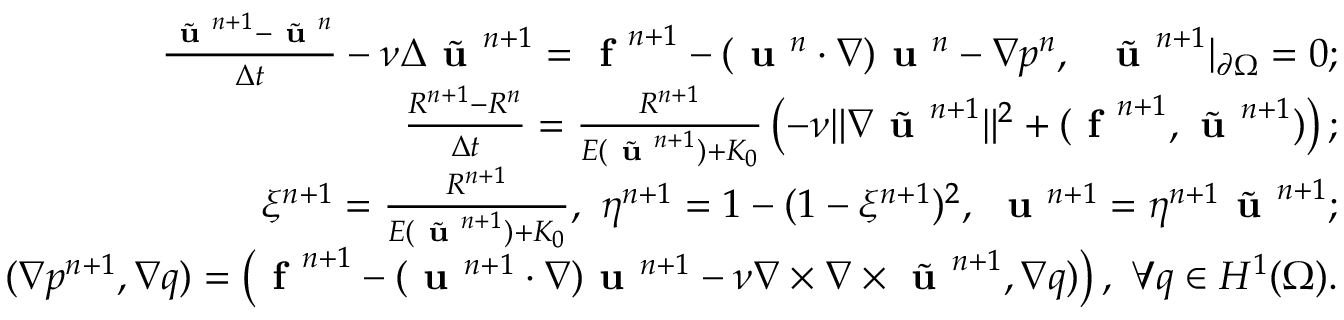Convert formula to latex. <formula><loc_0><loc_0><loc_500><loc_500>\begin{array} { r l r } & { \frac { \tilde { u } ^ { n + 1 } - \tilde { u } ^ { n } } { \Delta t } - \nu \Delta \tilde { u } ^ { n + 1 } = f ^ { n + 1 } - ( u ^ { n } \cdot \nabla ) u ^ { n } - \nabla p ^ { n } , \quad t i l d e { u } ^ { n + 1 } | _ { \partial \Omega } = 0 ; } \\ & { \frac { R ^ { n + 1 } - R ^ { n } } { \Delta t } = \frac { R ^ { n + 1 } } { E ( \tilde { u } ^ { n + 1 } ) + K _ { 0 } } \left ( - \nu \| \nabla \tilde { u } ^ { n + 1 } \| ^ { 2 } + ( f ^ { n + 1 } , \tilde { u } ^ { n + 1 } ) \right ) ; } \\ & { \xi ^ { n + 1 } = \frac { R ^ { n + 1 } } { E ( \tilde { u } ^ { n + 1 } ) + K _ { 0 } } , \ \eta ^ { n + 1 } = 1 - ( 1 - \xi ^ { n + 1 } ) ^ { 2 } , \ u ^ { n + 1 } = \eta ^ { n + 1 } \tilde { u } ^ { n + 1 } ; } \\ & { ( \nabla p ^ { n + 1 } , \nabla q ) = \left ( f ^ { n + 1 } - ( u ^ { n + 1 } \cdot \nabla ) u ^ { n + 1 } - \nu \nabla \times \nabla \times \tilde { u } ^ { n + 1 } , \nabla q ) \right ) , \ \forall q \in H ^ { 1 } ( \Omega ) . } \end{array}</formula> 